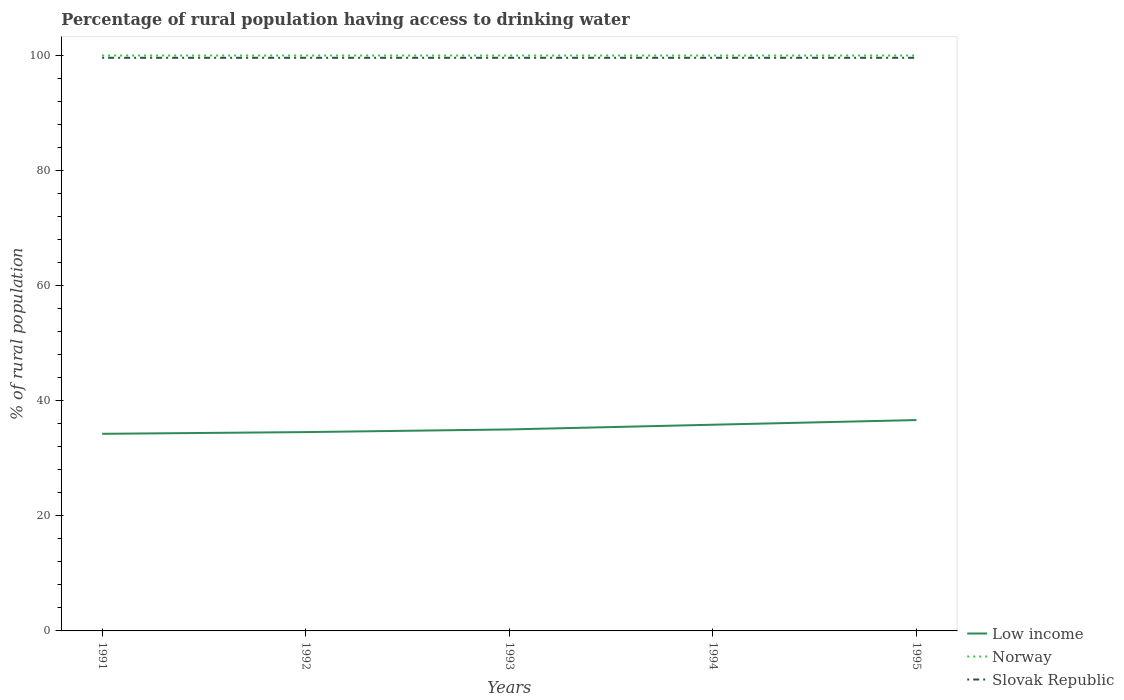How many different coloured lines are there?
Offer a terse response. 3. Is the number of lines equal to the number of legend labels?
Give a very brief answer. Yes. Across all years, what is the maximum percentage of rural population having access to drinking water in Low income?
Give a very brief answer. 34.25. In which year was the percentage of rural population having access to drinking water in Slovak Republic maximum?
Make the answer very short. 1991. What is the total percentage of rural population having access to drinking water in Low income in the graph?
Offer a terse response. -1.63. What is the difference between the highest and the second highest percentage of rural population having access to drinking water in Norway?
Ensure brevity in your answer.  0. Is the percentage of rural population having access to drinking water in Slovak Republic strictly greater than the percentage of rural population having access to drinking water in Norway over the years?
Offer a terse response. Yes. How many lines are there?
Your answer should be very brief. 3. What is the difference between two consecutive major ticks on the Y-axis?
Give a very brief answer. 20. How many legend labels are there?
Offer a terse response. 3. What is the title of the graph?
Your response must be concise. Percentage of rural population having access to drinking water. What is the label or title of the X-axis?
Provide a short and direct response. Years. What is the label or title of the Y-axis?
Provide a succinct answer. % of rural population. What is the % of rural population in Low income in 1991?
Offer a very short reply. 34.25. What is the % of rural population of Slovak Republic in 1991?
Provide a succinct answer. 99.6. What is the % of rural population of Low income in 1992?
Make the answer very short. 34.55. What is the % of rural population in Slovak Republic in 1992?
Keep it short and to the point. 99.6. What is the % of rural population of Low income in 1993?
Give a very brief answer. 35.01. What is the % of rural population of Slovak Republic in 1993?
Your response must be concise. 99.6. What is the % of rural population of Low income in 1994?
Keep it short and to the point. 35.83. What is the % of rural population in Slovak Republic in 1994?
Make the answer very short. 99.6. What is the % of rural population in Low income in 1995?
Provide a short and direct response. 36.64. What is the % of rural population in Slovak Republic in 1995?
Offer a very short reply. 99.6. Across all years, what is the maximum % of rural population of Low income?
Give a very brief answer. 36.64. Across all years, what is the maximum % of rural population of Slovak Republic?
Ensure brevity in your answer.  99.6. Across all years, what is the minimum % of rural population in Low income?
Your response must be concise. 34.25. Across all years, what is the minimum % of rural population of Norway?
Give a very brief answer. 100. Across all years, what is the minimum % of rural population in Slovak Republic?
Make the answer very short. 99.6. What is the total % of rural population in Low income in the graph?
Make the answer very short. 176.3. What is the total % of rural population of Norway in the graph?
Provide a short and direct response. 500. What is the total % of rural population in Slovak Republic in the graph?
Your response must be concise. 498. What is the difference between the % of rural population of Low income in 1991 and that in 1992?
Provide a short and direct response. -0.3. What is the difference between the % of rural population of Norway in 1991 and that in 1992?
Keep it short and to the point. 0. What is the difference between the % of rural population in Slovak Republic in 1991 and that in 1992?
Your answer should be compact. 0. What is the difference between the % of rural population of Low income in 1991 and that in 1993?
Ensure brevity in your answer.  -0.76. What is the difference between the % of rural population in Norway in 1991 and that in 1993?
Provide a succinct answer. 0. What is the difference between the % of rural population of Low income in 1991 and that in 1994?
Your answer should be very brief. -1.58. What is the difference between the % of rural population in Low income in 1991 and that in 1995?
Provide a succinct answer. -2.39. What is the difference between the % of rural population of Norway in 1991 and that in 1995?
Provide a short and direct response. 0. What is the difference between the % of rural population of Slovak Republic in 1991 and that in 1995?
Make the answer very short. 0. What is the difference between the % of rural population of Low income in 1992 and that in 1993?
Your answer should be very brief. -0.46. What is the difference between the % of rural population in Norway in 1992 and that in 1993?
Your answer should be compact. 0. What is the difference between the % of rural population in Slovak Republic in 1992 and that in 1993?
Make the answer very short. 0. What is the difference between the % of rural population in Low income in 1992 and that in 1994?
Offer a very short reply. -1.28. What is the difference between the % of rural population of Norway in 1992 and that in 1994?
Offer a terse response. 0. What is the difference between the % of rural population of Low income in 1992 and that in 1995?
Your response must be concise. -2.09. What is the difference between the % of rural population in Norway in 1992 and that in 1995?
Offer a terse response. 0. What is the difference between the % of rural population of Slovak Republic in 1992 and that in 1995?
Offer a very short reply. 0. What is the difference between the % of rural population in Low income in 1993 and that in 1994?
Make the answer very short. -0.82. What is the difference between the % of rural population in Slovak Republic in 1993 and that in 1994?
Ensure brevity in your answer.  0. What is the difference between the % of rural population of Low income in 1993 and that in 1995?
Provide a succinct answer. -1.63. What is the difference between the % of rural population in Norway in 1993 and that in 1995?
Ensure brevity in your answer.  0. What is the difference between the % of rural population of Slovak Republic in 1993 and that in 1995?
Your response must be concise. 0. What is the difference between the % of rural population in Low income in 1994 and that in 1995?
Ensure brevity in your answer.  -0.81. What is the difference between the % of rural population of Norway in 1994 and that in 1995?
Your answer should be very brief. 0. What is the difference between the % of rural population of Slovak Republic in 1994 and that in 1995?
Your answer should be compact. 0. What is the difference between the % of rural population of Low income in 1991 and the % of rural population of Norway in 1992?
Make the answer very short. -65.75. What is the difference between the % of rural population of Low income in 1991 and the % of rural population of Slovak Republic in 1992?
Ensure brevity in your answer.  -65.35. What is the difference between the % of rural population in Norway in 1991 and the % of rural population in Slovak Republic in 1992?
Provide a succinct answer. 0.4. What is the difference between the % of rural population in Low income in 1991 and the % of rural population in Norway in 1993?
Make the answer very short. -65.75. What is the difference between the % of rural population in Low income in 1991 and the % of rural population in Slovak Republic in 1993?
Give a very brief answer. -65.35. What is the difference between the % of rural population of Norway in 1991 and the % of rural population of Slovak Republic in 1993?
Your answer should be very brief. 0.4. What is the difference between the % of rural population of Low income in 1991 and the % of rural population of Norway in 1994?
Your answer should be compact. -65.75. What is the difference between the % of rural population of Low income in 1991 and the % of rural population of Slovak Republic in 1994?
Offer a very short reply. -65.35. What is the difference between the % of rural population of Norway in 1991 and the % of rural population of Slovak Republic in 1994?
Your answer should be very brief. 0.4. What is the difference between the % of rural population of Low income in 1991 and the % of rural population of Norway in 1995?
Keep it short and to the point. -65.75. What is the difference between the % of rural population of Low income in 1991 and the % of rural population of Slovak Republic in 1995?
Provide a short and direct response. -65.35. What is the difference between the % of rural population of Low income in 1992 and the % of rural population of Norway in 1993?
Provide a short and direct response. -65.45. What is the difference between the % of rural population of Low income in 1992 and the % of rural population of Slovak Republic in 1993?
Offer a very short reply. -65.05. What is the difference between the % of rural population of Norway in 1992 and the % of rural population of Slovak Republic in 1993?
Make the answer very short. 0.4. What is the difference between the % of rural population in Low income in 1992 and the % of rural population in Norway in 1994?
Keep it short and to the point. -65.45. What is the difference between the % of rural population in Low income in 1992 and the % of rural population in Slovak Republic in 1994?
Your answer should be compact. -65.05. What is the difference between the % of rural population in Low income in 1992 and the % of rural population in Norway in 1995?
Make the answer very short. -65.45. What is the difference between the % of rural population in Low income in 1992 and the % of rural population in Slovak Republic in 1995?
Your answer should be very brief. -65.05. What is the difference between the % of rural population of Norway in 1992 and the % of rural population of Slovak Republic in 1995?
Ensure brevity in your answer.  0.4. What is the difference between the % of rural population in Low income in 1993 and the % of rural population in Norway in 1994?
Provide a succinct answer. -64.99. What is the difference between the % of rural population in Low income in 1993 and the % of rural population in Slovak Republic in 1994?
Provide a short and direct response. -64.59. What is the difference between the % of rural population in Norway in 1993 and the % of rural population in Slovak Republic in 1994?
Offer a very short reply. 0.4. What is the difference between the % of rural population in Low income in 1993 and the % of rural population in Norway in 1995?
Keep it short and to the point. -64.99. What is the difference between the % of rural population in Low income in 1993 and the % of rural population in Slovak Republic in 1995?
Give a very brief answer. -64.59. What is the difference between the % of rural population in Low income in 1994 and the % of rural population in Norway in 1995?
Your response must be concise. -64.17. What is the difference between the % of rural population in Low income in 1994 and the % of rural population in Slovak Republic in 1995?
Give a very brief answer. -63.77. What is the difference between the % of rural population of Norway in 1994 and the % of rural population of Slovak Republic in 1995?
Provide a short and direct response. 0.4. What is the average % of rural population of Low income per year?
Offer a terse response. 35.26. What is the average % of rural population of Norway per year?
Give a very brief answer. 100. What is the average % of rural population in Slovak Republic per year?
Your response must be concise. 99.6. In the year 1991, what is the difference between the % of rural population of Low income and % of rural population of Norway?
Offer a terse response. -65.75. In the year 1991, what is the difference between the % of rural population of Low income and % of rural population of Slovak Republic?
Keep it short and to the point. -65.35. In the year 1992, what is the difference between the % of rural population of Low income and % of rural population of Norway?
Offer a very short reply. -65.45. In the year 1992, what is the difference between the % of rural population in Low income and % of rural population in Slovak Republic?
Your answer should be very brief. -65.05. In the year 1993, what is the difference between the % of rural population in Low income and % of rural population in Norway?
Your answer should be compact. -64.99. In the year 1993, what is the difference between the % of rural population in Low income and % of rural population in Slovak Republic?
Ensure brevity in your answer.  -64.59. In the year 1993, what is the difference between the % of rural population of Norway and % of rural population of Slovak Republic?
Offer a very short reply. 0.4. In the year 1994, what is the difference between the % of rural population in Low income and % of rural population in Norway?
Ensure brevity in your answer.  -64.17. In the year 1994, what is the difference between the % of rural population of Low income and % of rural population of Slovak Republic?
Provide a short and direct response. -63.77. In the year 1995, what is the difference between the % of rural population in Low income and % of rural population in Norway?
Provide a succinct answer. -63.36. In the year 1995, what is the difference between the % of rural population in Low income and % of rural population in Slovak Republic?
Give a very brief answer. -62.96. In the year 1995, what is the difference between the % of rural population in Norway and % of rural population in Slovak Republic?
Keep it short and to the point. 0.4. What is the ratio of the % of rural population of Slovak Republic in 1991 to that in 1992?
Your response must be concise. 1. What is the ratio of the % of rural population in Low income in 1991 to that in 1993?
Offer a terse response. 0.98. What is the ratio of the % of rural population in Slovak Republic in 1991 to that in 1993?
Your response must be concise. 1. What is the ratio of the % of rural population in Low income in 1991 to that in 1994?
Provide a succinct answer. 0.96. What is the ratio of the % of rural population in Low income in 1991 to that in 1995?
Your answer should be very brief. 0.93. What is the ratio of the % of rural population of Low income in 1992 to that in 1993?
Provide a short and direct response. 0.99. What is the ratio of the % of rural population of Low income in 1992 to that in 1994?
Your response must be concise. 0.96. What is the ratio of the % of rural population of Slovak Republic in 1992 to that in 1994?
Your answer should be very brief. 1. What is the ratio of the % of rural population in Low income in 1992 to that in 1995?
Your response must be concise. 0.94. What is the ratio of the % of rural population in Norway in 1992 to that in 1995?
Provide a succinct answer. 1. What is the ratio of the % of rural population in Slovak Republic in 1992 to that in 1995?
Your response must be concise. 1. What is the ratio of the % of rural population in Low income in 1993 to that in 1994?
Offer a very short reply. 0.98. What is the ratio of the % of rural population of Low income in 1993 to that in 1995?
Keep it short and to the point. 0.96. What is the ratio of the % of rural population of Norway in 1993 to that in 1995?
Your response must be concise. 1. What is the ratio of the % of rural population of Slovak Republic in 1993 to that in 1995?
Your answer should be compact. 1. What is the ratio of the % of rural population in Low income in 1994 to that in 1995?
Ensure brevity in your answer.  0.98. What is the ratio of the % of rural population of Norway in 1994 to that in 1995?
Provide a short and direct response. 1. What is the ratio of the % of rural population in Slovak Republic in 1994 to that in 1995?
Give a very brief answer. 1. What is the difference between the highest and the second highest % of rural population of Low income?
Your answer should be compact. 0.81. What is the difference between the highest and the second highest % of rural population in Norway?
Offer a terse response. 0. What is the difference between the highest and the second highest % of rural population of Slovak Republic?
Ensure brevity in your answer.  0. What is the difference between the highest and the lowest % of rural population in Low income?
Offer a very short reply. 2.39. What is the difference between the highest and the lowest % of rural population of Norway?
Provide a short and direct response. 0. 